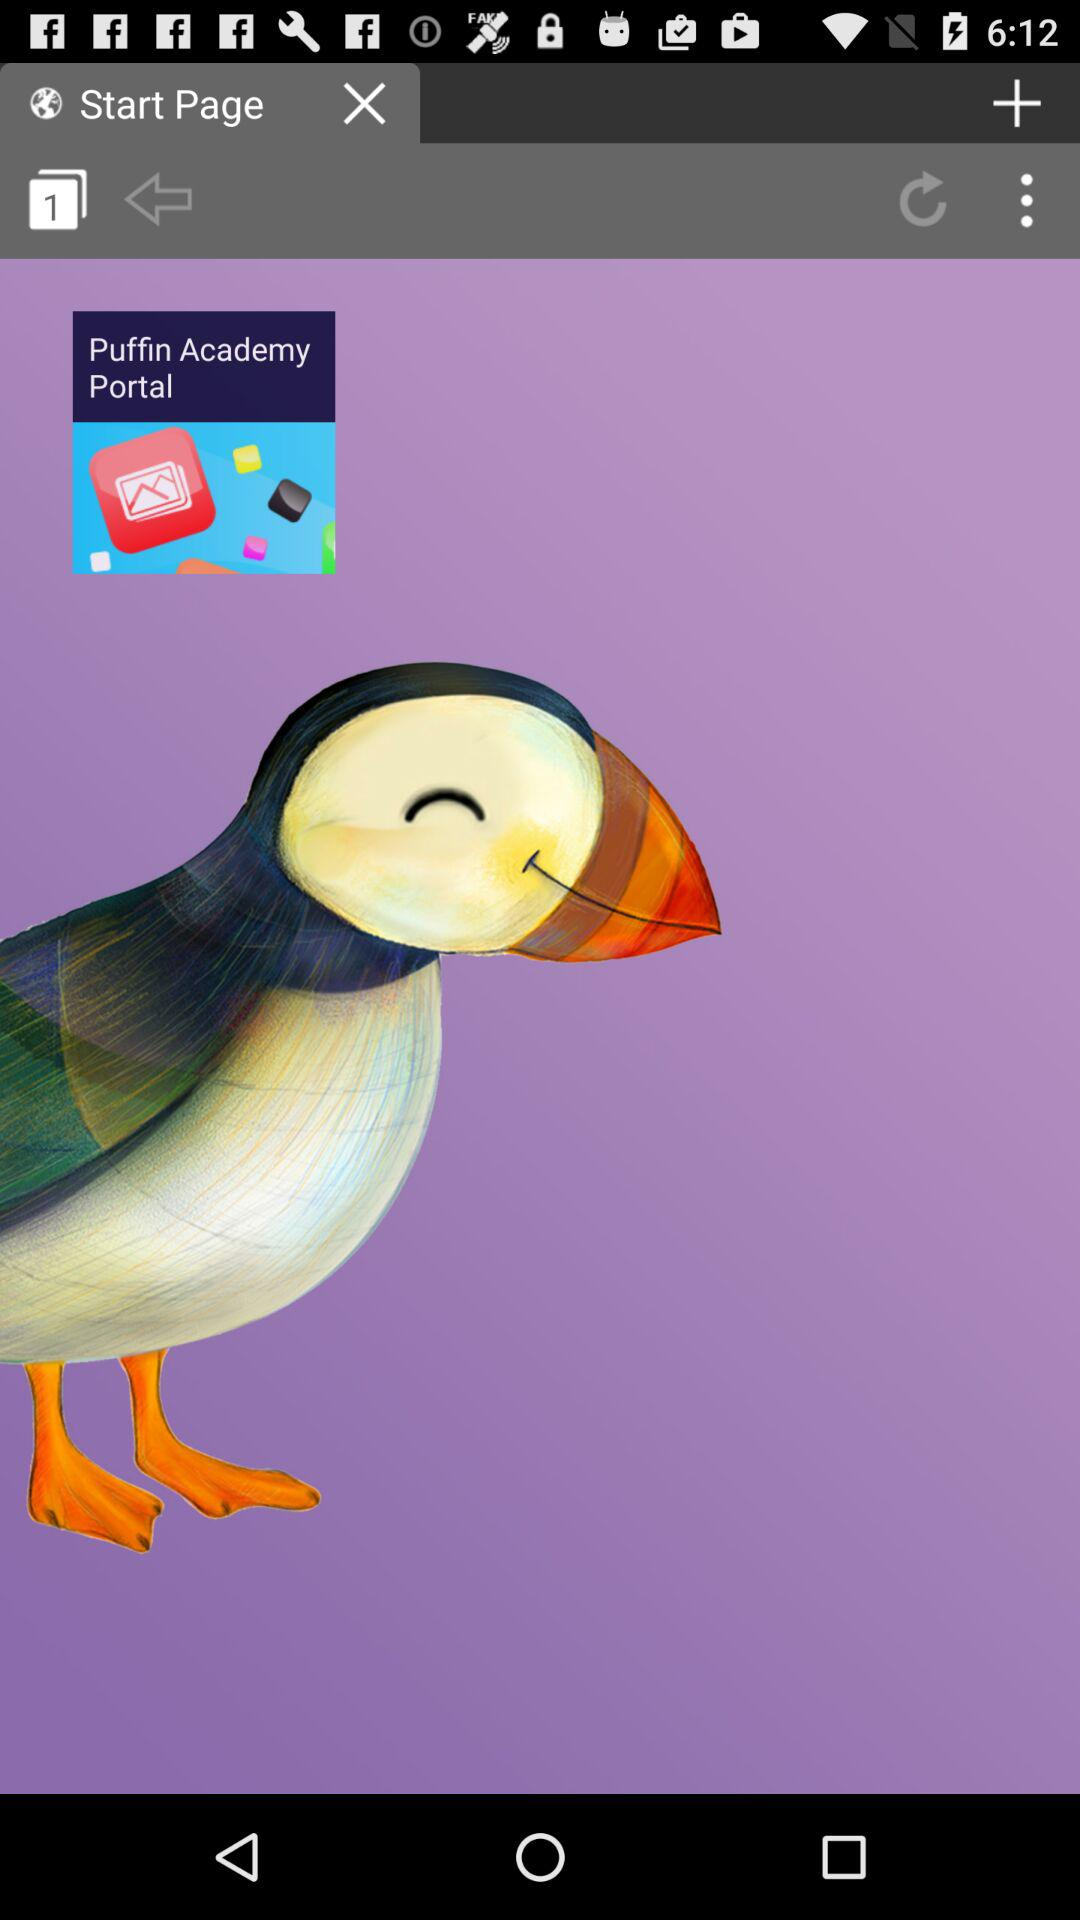What is the name of the application? The name of the application is "Puffin Academy". 